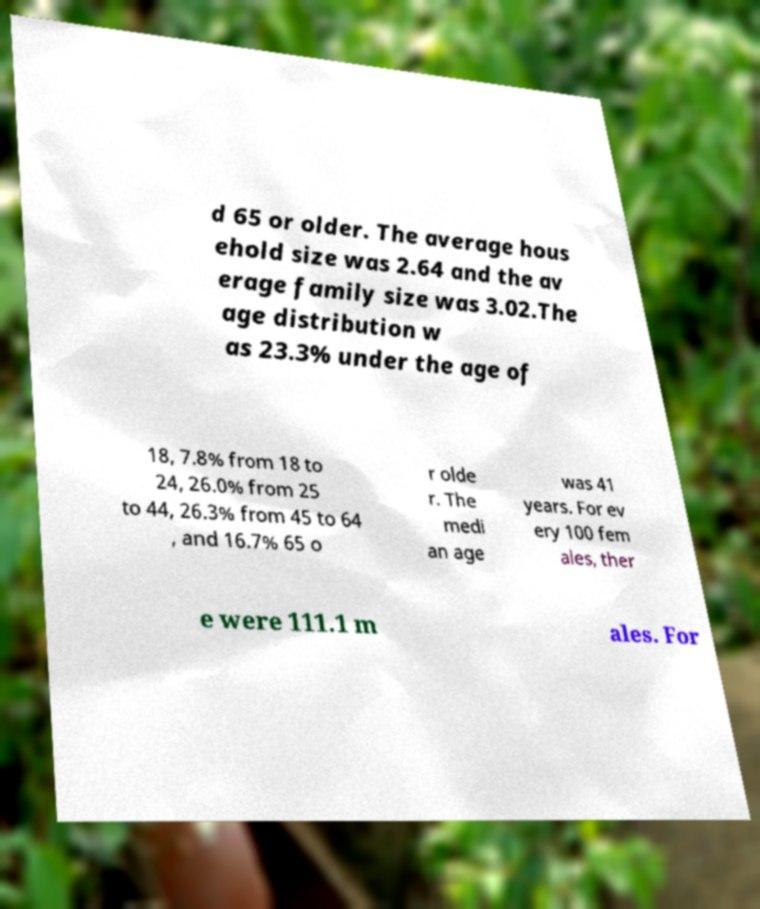Please identify and transcribe the text found in this image. d 65 or older. The average hous ehold size was 2.64 and the av erage family size was 3.02.The age distribution w as 23.3% under the age of 18, 7.8% from 18 to 24, 26.0% from 25 to 44, 26.3% from 45 to 64 , and 16.7% 65 o r olde r. The medi an age was 41 years. For ev ery 100 fem ales, ther e were 111.1 m ales. For 